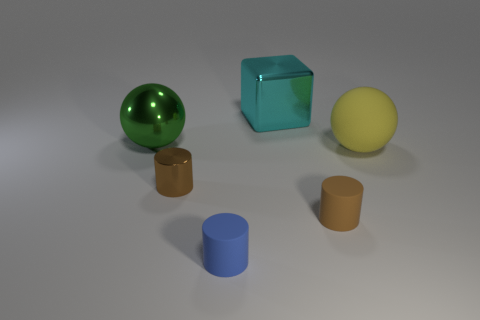The big object behind the big ball behind the big sphere that is on the right side of the metallic cylinder is what shape? cube 